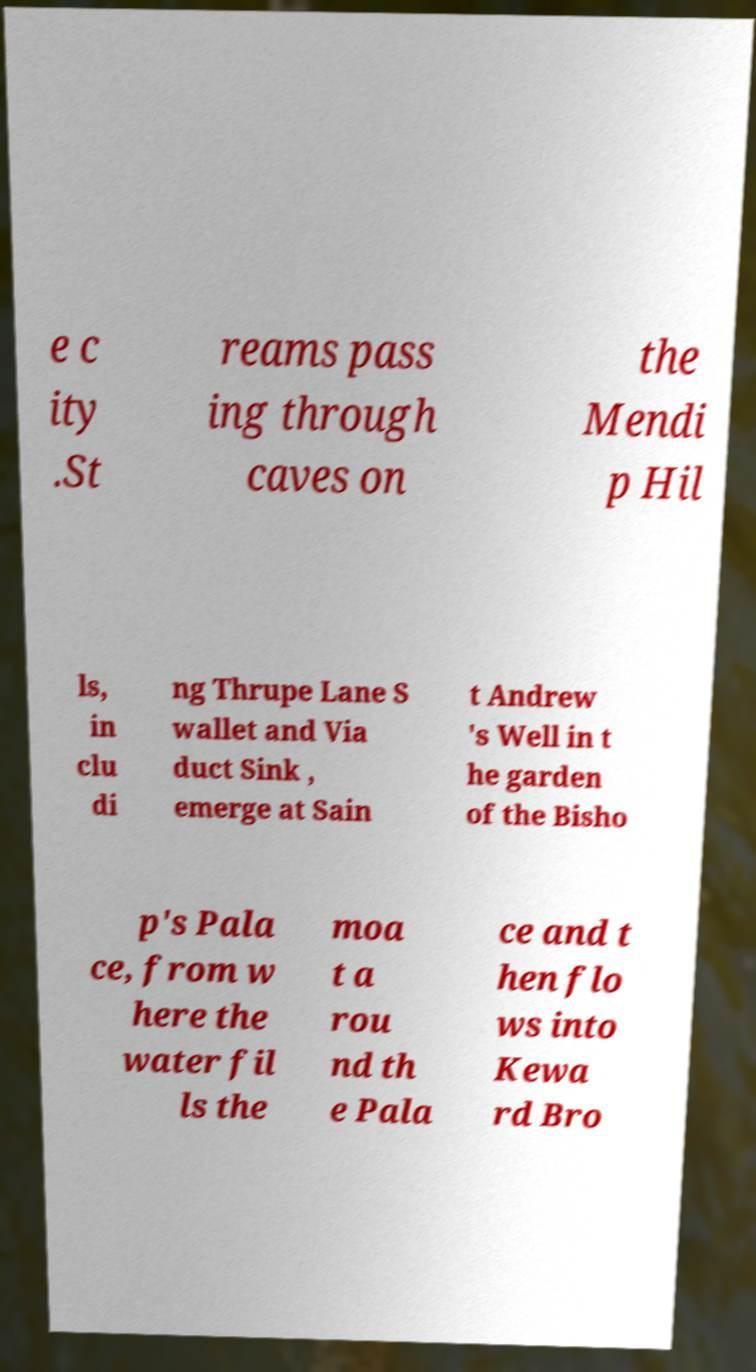Please identify and transcribe the text found in this image. e c ity .St reams pass ing through caves on the Mendi p Hil ls, in clu di ng Thrupe Lane S wallet and Via duct Sink , emerge at Sain t Andrew 's Well in t he garden of the Bisho p's Pala ce, from w here the water fil ls the moa t a rou nd th e Pala ce and t hen flo ws into Kewa rd Bro 